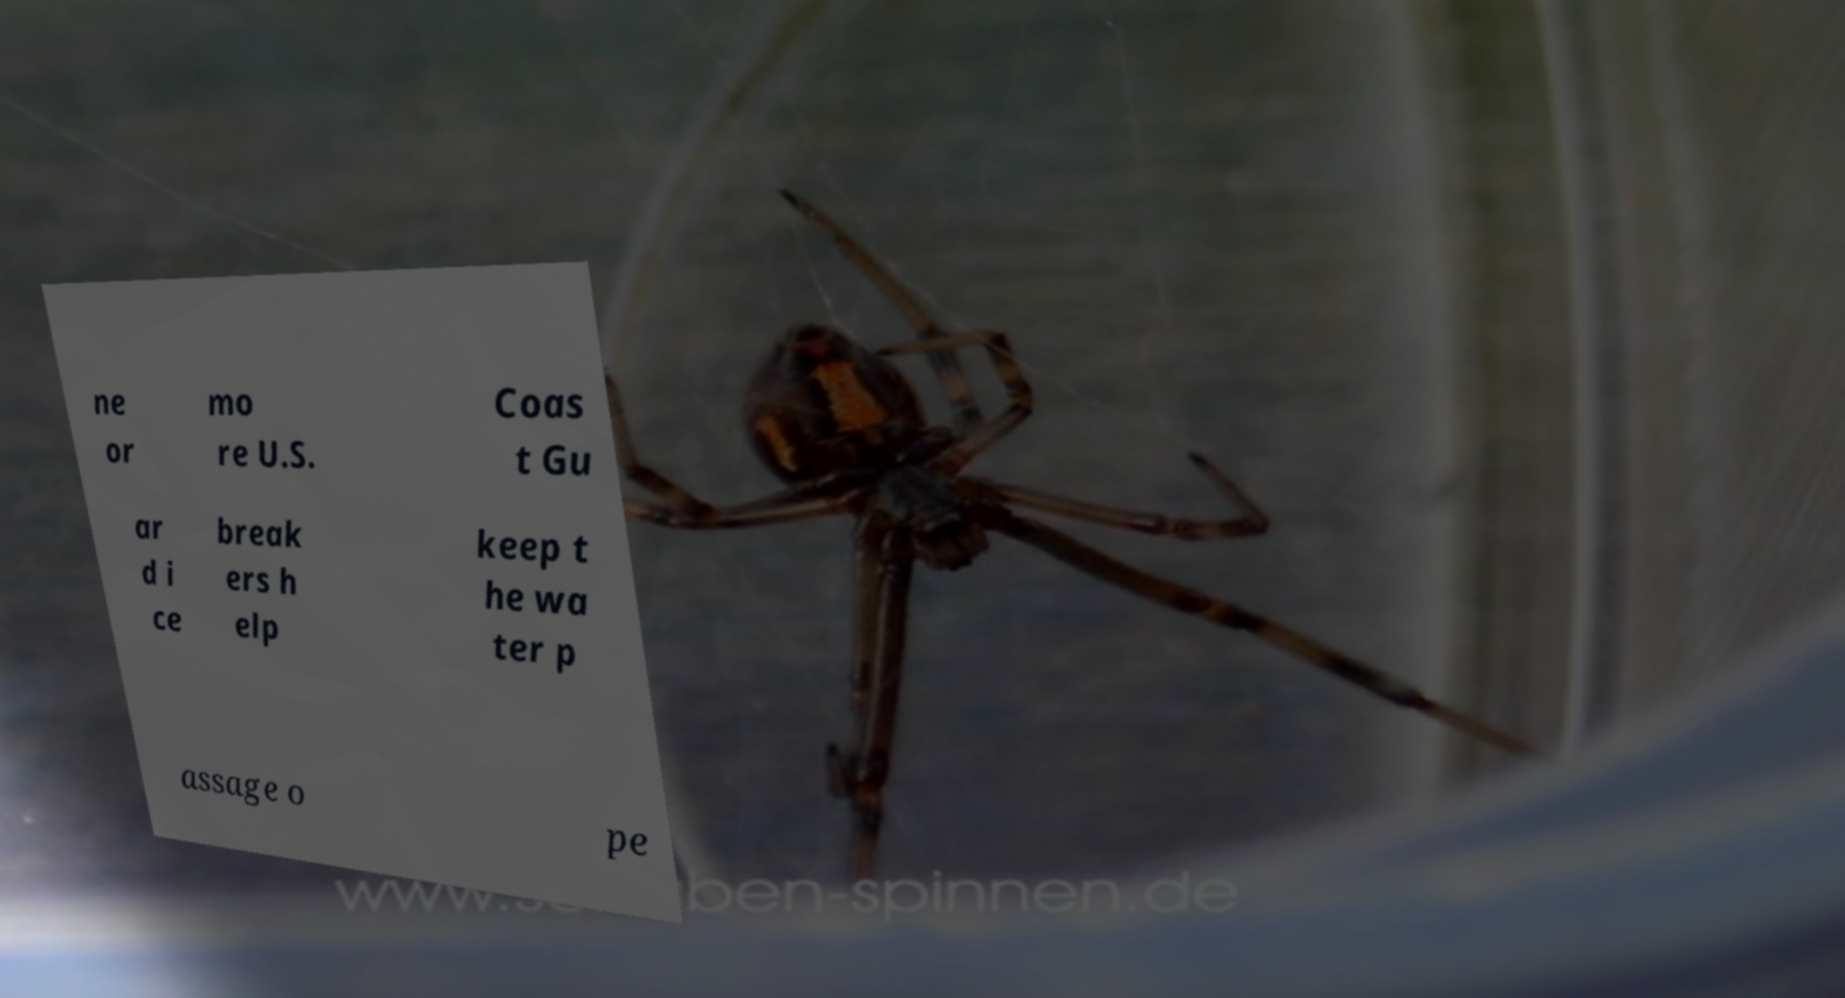Could you extract and type out the text from this image? ne or mo re U.S. Coas t Gu ar d i ce break ers h elp keep t he wa ter p assage o pe 